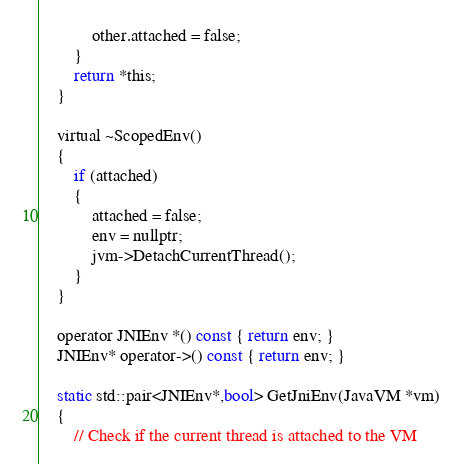<code> <loc_0><loc_0><loc_500><loc_500><_C_>            other.attached = false;
        }
        return *this;
    }

    virtual ~ScopedEnv()
    {
        if (attached)
        {
            attached = false;
            env = nullptr;
            jvm->DetachCurrentThread();
        }
    }

    operator JNIEnv *() const { return env; }
    JNIEnv* operator->() const { return env; }

    static std::pair<JNIEnv*,bool> GetJniEnv(JavaVM *vm)
    {
        // Check if the current thread is attached to the VM</code> 